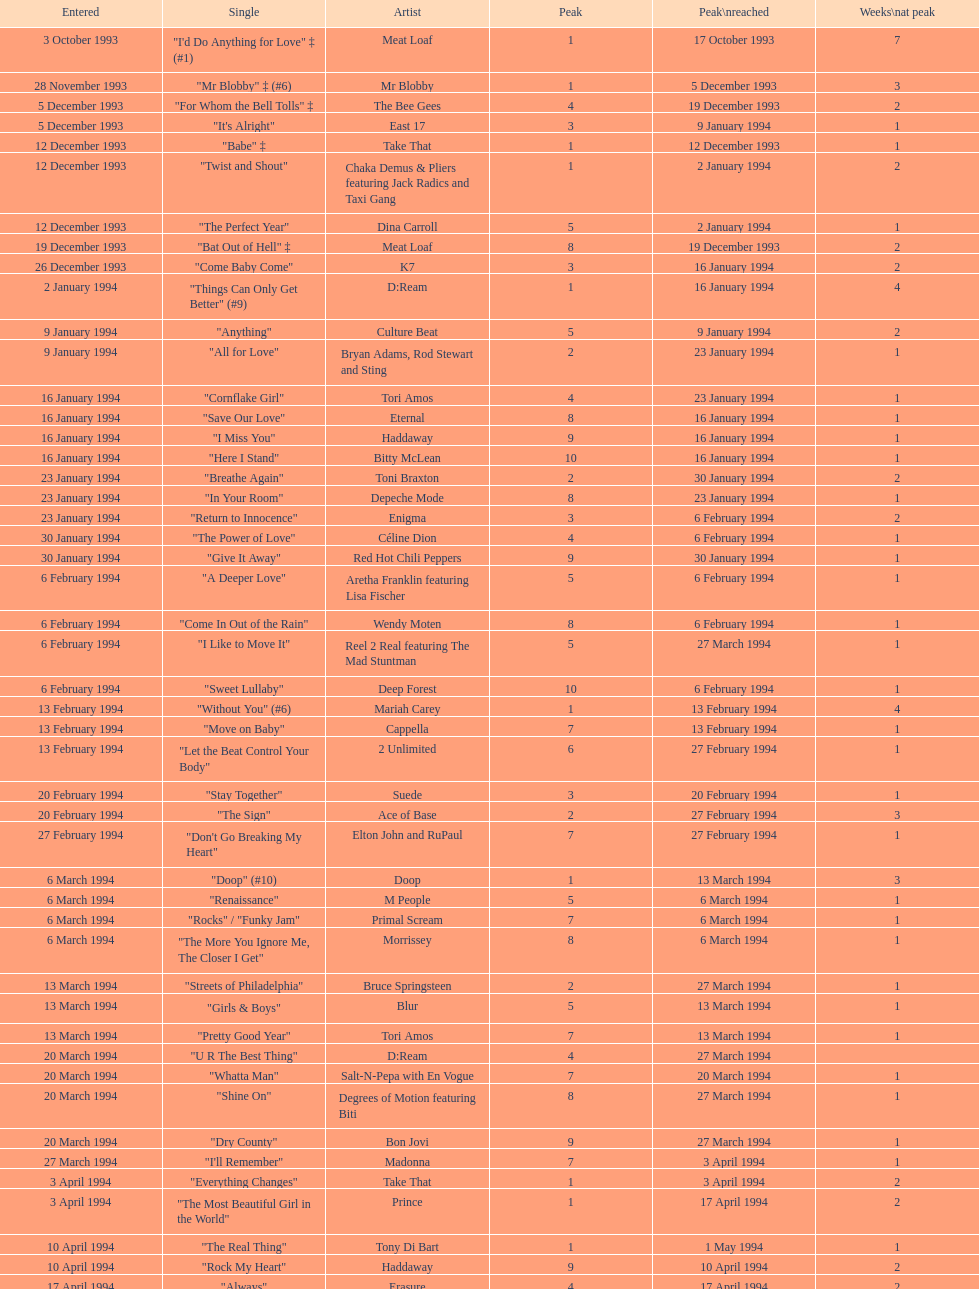Which musician's sole single was introduced on january 2, 1994? D:Ream. Give me the full table as a dictionary. {'header': ['Entered', 'Single', 'Artist', 'Peak', 'Peak\\nreached', 'Weeks\\nat peak'], 'rows': [['3 October 1993', '"I\'d Do Anything for Love" ‡ (#1)', 'Meat Loaf', '1', '17 October 1993', '7'], ['28 November 1993', '"Mr Blobby" ‡ (#6)', 'Mr Blobby', '1', '5 December 1993', '3'], ['5 December 1993', '"For Whom the Bell Tolls" ‡', 'The Bee Gees', '4', '19 December 1993', '2'], ['5 December 1993', '"It\'s Alright"', 'East 17', '3', '9 January 1994', '1'], ['12 December 1993', '"Babe" ‡', 'Take That', '1', '12 December 1993', '1'], ['12 December 1993', '"Twist and Shout"', 'Chaka Demus & Pliers featuring Jack Radics and Taxi Gang', '1', '2 January 1994', '2'], ['12 December 1993', '"The Perfect Year"', 'Dina Carroll', '5', '2 January 1994', '1'], ['19 December 1993', '"Bat Out of Hell" ‡', 'Meat Loaf', '8', '19 December 1993', '2'], ['26 December 1993', '"Come Baby Come"', 'K7', '3', '16 January 1994', '2'], ['2 January 1994', '"Things Can Only Get Better" (#9)', 'D:Ream', '1', '16 January 1994', '4'], ['9 January 1994', '"Anything"', 'Culture Beat', '5', '9 January 1994', '2'], ['9 January 1994', '"All for Love"', 'Bryan Adams, Rod Stewart and Sting', '2', '23 January 1994', '1'], ['16 January 1994', '"Cornflake Girl"', 'Tori Amos', '4', '23 January 1994', '1'], ['16 January 1994', '"Save Our Love"', 'Eternal', '8', '16 January 1994', '1'], ['16 January 1994', '"I Miss You"', 'Haddaway', '9', '16 January 1994', '1'], ['16 January 1994', '"Here I Stand"', 'Bitty McLean', '10', '16 January 1994', '1'], ['23 January 1994', '"Breathe Again"', 'Toni Braxton', '2', '30 January 1994', '2'], ['23 January 1994', '"In Your Room"', 'Depeche Mode', '8', '23 January 1994', '1'], ['23 January 1994', '"Return to Innocence"', 'Enigma', '3', '6 February 1994', '2'], ['30 January 1994', '"The Power of Love"', 'Céline Dion', '4', '6 February 1994', '1'], ['30 January 1994', '"Give It Away"', 'Red Hot Chili Peppers', '9', '30 January 1994', '1'], ['6 February 1994', '"A Deeper Love"', 'Aretha Franklin featuring Lisa Fischer', '5', '6 February 1994', '1'], ['6 February 1994', '"Come In Out of the Rain"', 'Wendy Moten', '8', '6 February 1994', '1'], ['6 February 1994', '"I Like to Move It"', 'Reel 2 Real featuring The Mad Stuntman', '5', '27 March 1994', '1'], ['6 February 1994', '"Sweet Lullaby"', 'Deep Forest', '10', '6 February 1994', '1'], ['13 February 1994', '"Without You" (#6)', 'Mariah Carey', '1', '13 February 1994', '4'], ['13 February 1994', '"Move on Baby"', 'Cappella', '7', '13 February 1994', '1'], ['13 February 1994', '"Let the Beat Control Your Body"', '2 Unlimited', '6', '27 February 1994', '1'], ['20 February 1994', '"Stay Together"', 'Suede', '3', '20 February 1994', '1'], ['20 February 1994', '"The Sign"', 'Ace of Base', '2', '27 February 1994', '3'], ['27 February 1994', '"Don\'t Go Breaking My Heart"', 'Elton John and RuPaul', '7', '27 February 1994', '1'], ['6 March 1994', '"Doop" (#10)', 'Doop', '1', '13 March 1994', '3'], ['6 March 1994', '"Renaissance"', 'M People', '5', '6 March 1994', '1'], ['6 March 1994', '"Rocks" / "Funky Jam"', 'Primal Scream', '7', '6 March 1994', '1'], ['6 March 1994', '"The More You Ignore Me, The Closer I Get"', 'Morrissey', '8', '6 March 1994', '1'], ['13 March 1994', '"Streets of Philadelphia"', 'Bruce Springsteen', '2', '27 March 1994', '1'], ['13 March 1994', '"Girls & Boys"', 'Blur', '5', '13 March 1994', '1'], ['13 March 1994', '"Pretty Good Year"', 'Tori Amos', '7', '13 March 1994', '1'], ['20 March 1994', '"U R The Best Thing"', 'D:Ream', '4', '27 March 1994', ''], ['20 March 1994', '"Whatta Man"', 'Salt-N-Pepa with En Vogue', '7', '20 March 1994', '1'], ['20 March 1994', '"Shine On"', 'Degrees of Motion featuring Biti', '8', '27 March 1994', '1'], ['20 March 1994', '"Dry County"', 'Bon Jovi', '9', '27 March 1994', '1'], ['27 March 1994', '"I\'ll Remember"', 'Madonna', '7', '3 April 1994', '1'], ['3 April 1994', '"Everything Changes"', 'Take That', '1', '3 April 1994', '2'], ['3 April 1994', '"The Most Beautiful Girl in the World"', 'Prince', '1', '17 April 1994', '2'], ['10 April 1994', '"The Real Thing"', 'Tony Di Bart', '1', '1 May 1994', '1'], ['10 April 1994', '"Rock My Heart"', 'Haddaway', '9', '10 April 1994', '2'], ['17 April 1994', '"Always"', 'Erasure', '4', '17 April 1994', '2'], ['17 April 1994', '"Mmm Mmm Mmm Mmm"', 'Crash Test Dummies', '2', '24 April 1994', '1'], ['17 April 1994', '"Dedicated to the One I Love"', 'Bitty McLean', '6', '24 April 1994', '1'], ['24 April 1994', '"Sweets for My Sweet"', 'C.J. Lewis', '3', '1 May 1994', '1'], ['24 April 1994', '"I\'ll Stand by You"', 'The Pretenders', '10', '24 April 1994', '1'], ['1 May 1994', '"Inside"', 'Stiltskin', '1', '8 May 1994', '1'], ['1 May 1994', '"Light My Fire"', 'Clubhouse featuring Carl', '7', '1 May 1994', '1'], ['1 May 1994', '"Come on You Reds"', 'Manchester United Football Squad featuring Status Quo', '1', '15 May 1994', '2'], ['8 May 1994', '"Around the World"', 'East 17', '3', '15 May 1994', '2'], ['8 May 1994', '"Just a Step from Heaven"', 'Eternal', '8', '15 May 1994', '1'], ['15 May 1994', '"Love Is All Around" (#1)', 'Wet Wet Wet', '1', '29 May 1994', '15'], ['15 May 1994', '"The Real Thing"', '2 Unlimited', '6', '22 May 1994', '1'], ['15 May 1994', '"More to This World"', 'Bad Boys Inc', '8', '22 May 1994', '1'], ['22 May 1994', '"Get-A-Way"', 'Maxx', '4', '29 May 1994', '2'], ['22 May 1994', '"No Good (Start the Dance)"', 'The Prodigy', '4', '12 June 1994', '1'], ['29 May 1994', '"Baby, I Love Your Way"', 'Big Mountain', '2', '5 June 1994', '3'], ['29 May 1994', '"Carry Me Home"', 'Gloworm', '9', '29 May 1994', '1'], ['5 June 1994', '"Absolutely Fabulous"', 'Absolutely Fabulous', '6', '12 June 1994', '1'], ['5 June 1994', '"You Don\'t Love Me (No, No, No)"', 'Dawn Penn', '3', '12 June 1994', '2'], ['5 June 1994', '"Since I Don\'t Have You"', 'Guns N Roses', '10', '5 June 1994', '1'], ['12 June 1994', '"Don\'t Turn Around"', 'Ace of Base', '5', '19 June 1994', '1'], ['12 June 1994', '"Swamp Thing"', 'The Grid', '3', '26 June 1994', '1'], ['12 June 1994', '"Anytime You Need a Friend"', 'Mariah Carey', '8', '19 June 1994', '1'], ['19 June 1994', '"I Swear" (#5)', 'All-4-One', '2', '26 June 1994', '7'], ['26 June 1994', '"Go On Move"', 'Reel 2 Real featuring The Mad Stuntman', '7', '26 June 1994', '2'], ['26 June 1994', '"Shine"', 'Aswad', '5', '17 July 1994', '1'], ['26 June 1994', '"U & Me"', 'Cappella', '10', '26 June 1994', '1'], ['3 July 1994', '"Love Ain\'t Here Anymore"', 'Take That', '3', '3 July 1994', '2'], ['3 July 1994', '"(Meet) The Flintstones"', 'The B.C. 52s', '3', '17 July 1994', '3'], ['3 July 1994', '"Word Up!"', 'GUN', '8', '3 July 1994', '1'], ['10 July 1994', '"Everybody Gonfi-Gon"', '2 Cowboys', '7', '10 July 1994', '1'], ['10 July 1994', '"Crazy for You" (#8)', 'Let Loose', '2', '14 August 1994', '2'], ['17 July 1994', '"Regulate"', 'Warren G and Nate Dogg', '5', '24 July 1994', '1'], ['17 July 1994', '"Everything is Alright (Uptight)"', 'C.J. Lewis', '10', '17 July 1994', '2'], ['24 July 1994', '"Run to the Sun"', 'Erasure', '6', '24 July 1994', '1'], ['24 July 1994', '"Searching"', 'China Black', '4', '7 August 1994', '2'], ['31 July 1994', '"Let\'s Get Ready to Rhumble"', 'PJ & Duncan', '1', '31 March 2013', '1'], ['31 July 1994', '"No More (I Can\'t Stand It)"', 'Maxx', '8', '7 August 1994', '1'], ['7 August 1994', '"Compliments on Your Kiss"', 'Red Dragon with Brian and Tony Gold', '2', '28 August 1994', '1'], ['7 August 1994', '"What\'s Up?"', 'DJ Miko', '6', '14 August 1994', '1'], ['14 August 1994', '"7 Seconds"', "Youssou N'Dour featuring Neneh Cherry", '3', '4 September 1994', '1'], ['14 August 1994', '"Live Forever"', 'Oasis', '10', '14 August 1994', '2'], ['21 August 1994', '"Eighteen Strings"', 'Tinman', '9', '21 August 1994', '1'], ['28 August 1994', '"I\'ll Make Love to You"', 'Boyz II Men', '5', '4 September 1994', '1'], ['28 August 1994', '"Parklife"', 'Blur', '10', '28 August 1994', '1'], ['4 September 1994', '"Confide in Me"', 'Kylie Minogue', '2', '4 September 1994', '1'], ['4 September 1994', '"The Rhythm of the Night"', 'Corona', '2', '18 September 1994', '2'], ['11 September 1994', '"Saturday Night" (#2)', 'Whigfield', '1', '11 September 1994', '4'], ['11 September 1994', '"Endless Love"', 'Luther Vandross and Mariah Carey', '3', '11 September 1994', '2'], ['11 September 1994', '"What\'s the Frequency, Kenneth"', 'R.E.M.', '9', '11 September 1994', '1'], ['11 September 1994', '"Incredible"', 'M-Beat featuring General Levy', '8', '18 September 1994', '1'], ['18 September 1994', '"Always" (#7)', 'Bon Jovi', '2', '2 October 1994', '3'], ['25 September 1994', '"Hey Now (Girls Just Want to Have Fun)"', 'Cyndi Lauper', '4', '2 October 1994', '1'], ['25 September 1994', '"Stay (I Missed You)"', 'Lisa Loeb and Nine Stories', '6', '25 September 1994', '1'], ['25 September 1994', '"Steam"', 'East 17', '7', '25 September 1994', '2'], ['2 October 1994', '"Secret"', 'Madonna', '5', '2 October 1994', '1'], ['2 October 1994', '"Baby Come Back" (#4)', 'Pato Banton featuring Ali and Robin Campbell', '1', '23 October 1994', '4'], ['2 October 1994', '"Sweetness"', 'Michelle Gayle', '4', '30 October 1994', '1'], ['9 October 1994', '"Sure"', 'Take That', '1', '9 October 1994', '2'], ['16 October 1994', '"Cigarettes & Alcohol"', 'Oasis', '7', '16 October 1994', '1'], ['16 October 1994', '"Welcome to Tomorrow (Are You Ready?)"', 'Snap! featuring Summer', '6', '30 October 1994', '1'], ['16 October 1994', '"She\'s Got That Vibe"', 'R. Kelly', '3', '6 November 1994', '1'], ['23 October 1994', '"When We Dance"', 'Sting', '9', '23 October 1994', '1'], ['30 October 1994', '"Oh Baby I..."', 'Eternal', '4', '6 November 1994', '1'], ['30 October 1994', '"Some Girls"', 'Ultimate Kaos', '9', '30 October 1994', '1'], ['6 November 1994', '"Another Night"', 'MC Sar and Real McCoy', '2', '13 November 1994', '1'], ['6 November 1994', '"All I Wanna Do"', 'Sheryl Crow', '4', '20 November 1994', '1'], ['13 November 1994', '"Let Me Be Your Fantasy"', 'Baby D', '1', '20 November 1994', '2'], ['13 November 1994', '"Sight for Sore Eyes"', 'M People', '6', '20 November 1994', '1'], ['13 November 1994', '"True Faith \'94"', 'New Order', '9', '13 November 1994', '1'], ['20 November 1994', '"We Have All the Time in the World"', 'Louis Armstrong', '3', '27 November 1994', '1'], ['20 November 1994', '"Crocodile Shoes"', 'Jimmy Nail', '4', '4 December 1994', '1'], ['20 November 1994', '"Spin the Black Circle"', 'Pearl Jam', '10', '20 November 1994', '1'], ['27 November 1994', '"Love Spreads"', 'The Stone Roses', '2', '27 November 1994', '1'], ['27 November 1994', '"Stay Another Day" (#3)', 'East 17', '1', '4 December 1994', '5'], ['4 December 1994', '"All I Want for Christmas Is You"', 'Mariah Carey', '2', '11 December 1994', '3'], ['11 December 1994', '"Power Rangers: The Official Single"', 'The Mighty RAW', '3', '11 December', '1'], ['4 December 1994', '"Think Twice" ♦', 'Celine Dion', '1', '29 January 1995', '7'], ['4 December 1994', '"Love Me for a Reason" ♦', 'Boyzone', '2', '1 January 1995', '1'], ['11 December 1994', '"Please Come Home for Christmas"', 'Bon Jovi', '7', '11 December 1994', '1'], ['11 December 1994', '"Another Day" ♦', 'Whigfield', '7', '1 January 1995', '1'], ['18 December 1994', '"Cotton Eye Joe" ♦', 'Rednex', '1', '8 January 1995', '3'], ['18 December 1994', '"Them Girls, Them Girls" ♦', 'Zig and Zag', '5', '1 January 1995', '1'], ['25 December 1994', '"Whatever"', 'Oasis', '3', '25 December 1994', '1']]} 